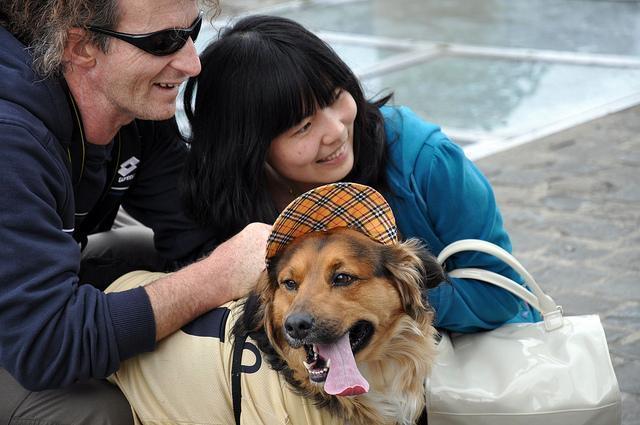How many people are there?
Give a very brief answer. 2. 